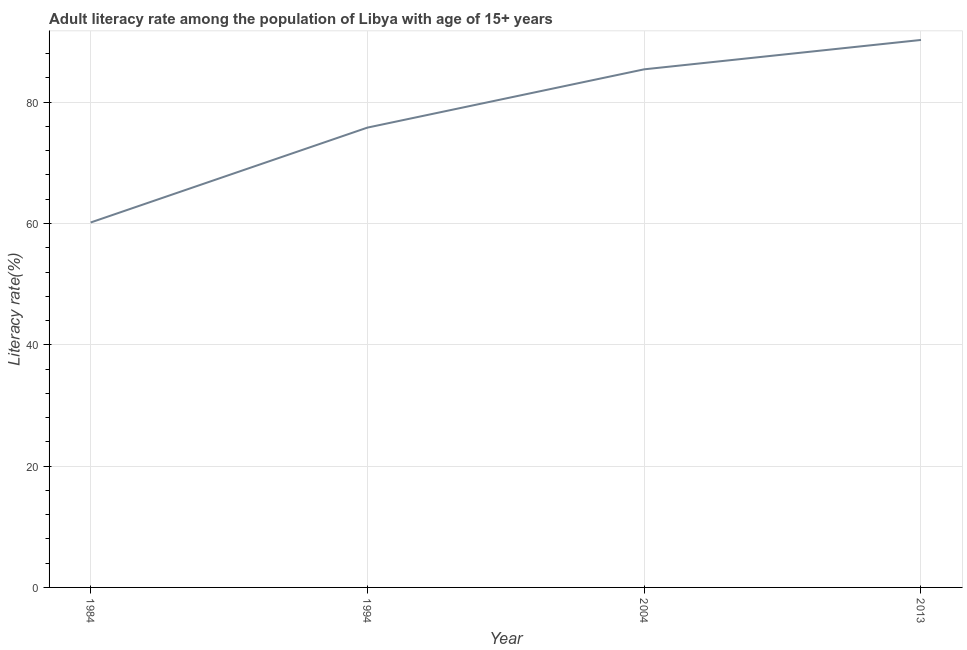What is the adult literacy rate in 2004?
Make the answer very short. 85.42. Across all years, what is the maximum adult literacy rate?
Your answer should be very brief. 90.26. Across all years, what is the minimum adult literacy rate?
Your answer should be compact. 60.16. In which year was the adult literacy rate minimum?
Offer a very short reply. 1984. What is the sum of the adult literacy rate?
Provide a short and direct response. 311.65. What is the difference between the adult literacy rate in 1994 and 2004?
Your response must be concise. -9.61. What is the average adult literacy rate per year?
Your answer should be compact. 77.91. What is the median adult literacy rate?
Offer a terse response. 80.61. What is the ratio of the adult literacy rate in 1984 to that in 2004?
Make the answer very short. 0.7. Is the difference between the adult literacy rate in 1994 and 2013 greater than the difference between any two years?
Provide a succinct answer. No. What is the difference between the highest and the second highest adult literacy rate?
Your response must be concise. 4.84. What is the difference between the highest and the lowest adult literacy rate?
Make the answer very short. 30.09. In how many years, is the adult literacy rate greater than the average adult literacy rate taken over all years?
Offer a very short reply. 2. How many lines are there?
Offer a very short reply. 1. How many years are there in the graph?
Keep it short and to the point. 4. What is the difference between two consecutive major ticks on the Y-axis?
Offer a very short reply. 20. Does the graph contain grids?
Offer a very short reply. Yes. What is the title of the graph?
Give a very brief answer. Adult literacy rate among the population of Libya with age of 15+ years. What is the label or title of the Y-axis?
Ensure brevity in your answer.  Literacy rate(%). What is the Literacy rate(%) in 1984?
Ensure brevity in your answer.  60.16. What is the Literacy rate(%) in 1994?
Provide a succinct answer. 75.81. What is the Literacy rate(%) of 2004?
Keep it short and to the point. 85.42. What is the Literacy rate(%) in 2013?
Keep it short and to the point. 90.26. What is the difference between the Literacy rate(%) in 1984 and 1994?
Offer a terse response. -15.64. What is the difference between the Literacy rate(%) in 1984 and 2004?
Give a very brief answer. -25.25. What is the difference between the Literacy rate(%) in 1984 and 2013?
Offer a very short reply. -30.09. What is the difference between the Literacy rate(%) in 1994 and 2004?
Provide a short and direct response. -9.61. What is the difference between the Literacy rate(%) in 1994 and 2013?
Your answer should be compact. -14.45. What is the difference between the Literacy rate(%) in 2004 and 2013?
Keep it short and to the point. -4.84. What is the ratio of the Literacy rate(%) in 1984 to that in 1994?
Provide a succinct answer. 0.79. What is the ratio of the Literacy rate(%) in 1984 to that in 2004?
Your answer should be compact. 0.7. What is the ratio of the Literacy rate(%) in 1984 to that in 2013?
Offer a very short reply. 0.67. What is the ratio of the Literacy rate(%) in 1994 to that in 2004?
Your response must be concise. 0.89. What is the ratio of the Literacy rate(%) in 1994 to that in 2013?
Your response must be concise. 0.84. What is the ratio of the Literacy rate(%) in 2004 to that in 2013?
Your answer should be very brief. 0.95. 